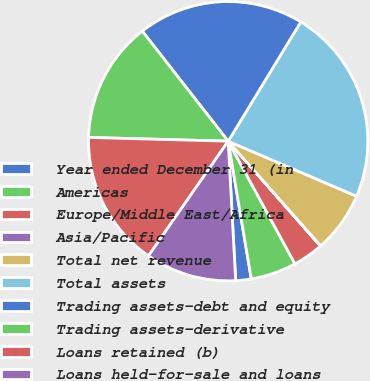Convert chart to OTSL. <chart><loc_0><loc_0><loc_500><loc_500><pie_chart><fcel>Year ended December 31 (in<fcel>Americas<fcel>Europe/Middle East/Africa<fcel>Asia/Pacific<fcel>Total net revenue<fcel>Total assets<fcel>Trading assets-debt and equity<fcel>Trading assets-derivative<fcel>Loans retained (b)<fcel>Loans held-for-sale and loans<nl><fcel>1.79%<fcel>5.29%<fcel>3.54%<fcel>0.05%<fcel>7.03%<fcel>22.74%<fcel>19.25%<fcel>14.02%<fcel>15.76%<fcel>10.52%<nl></chart> 